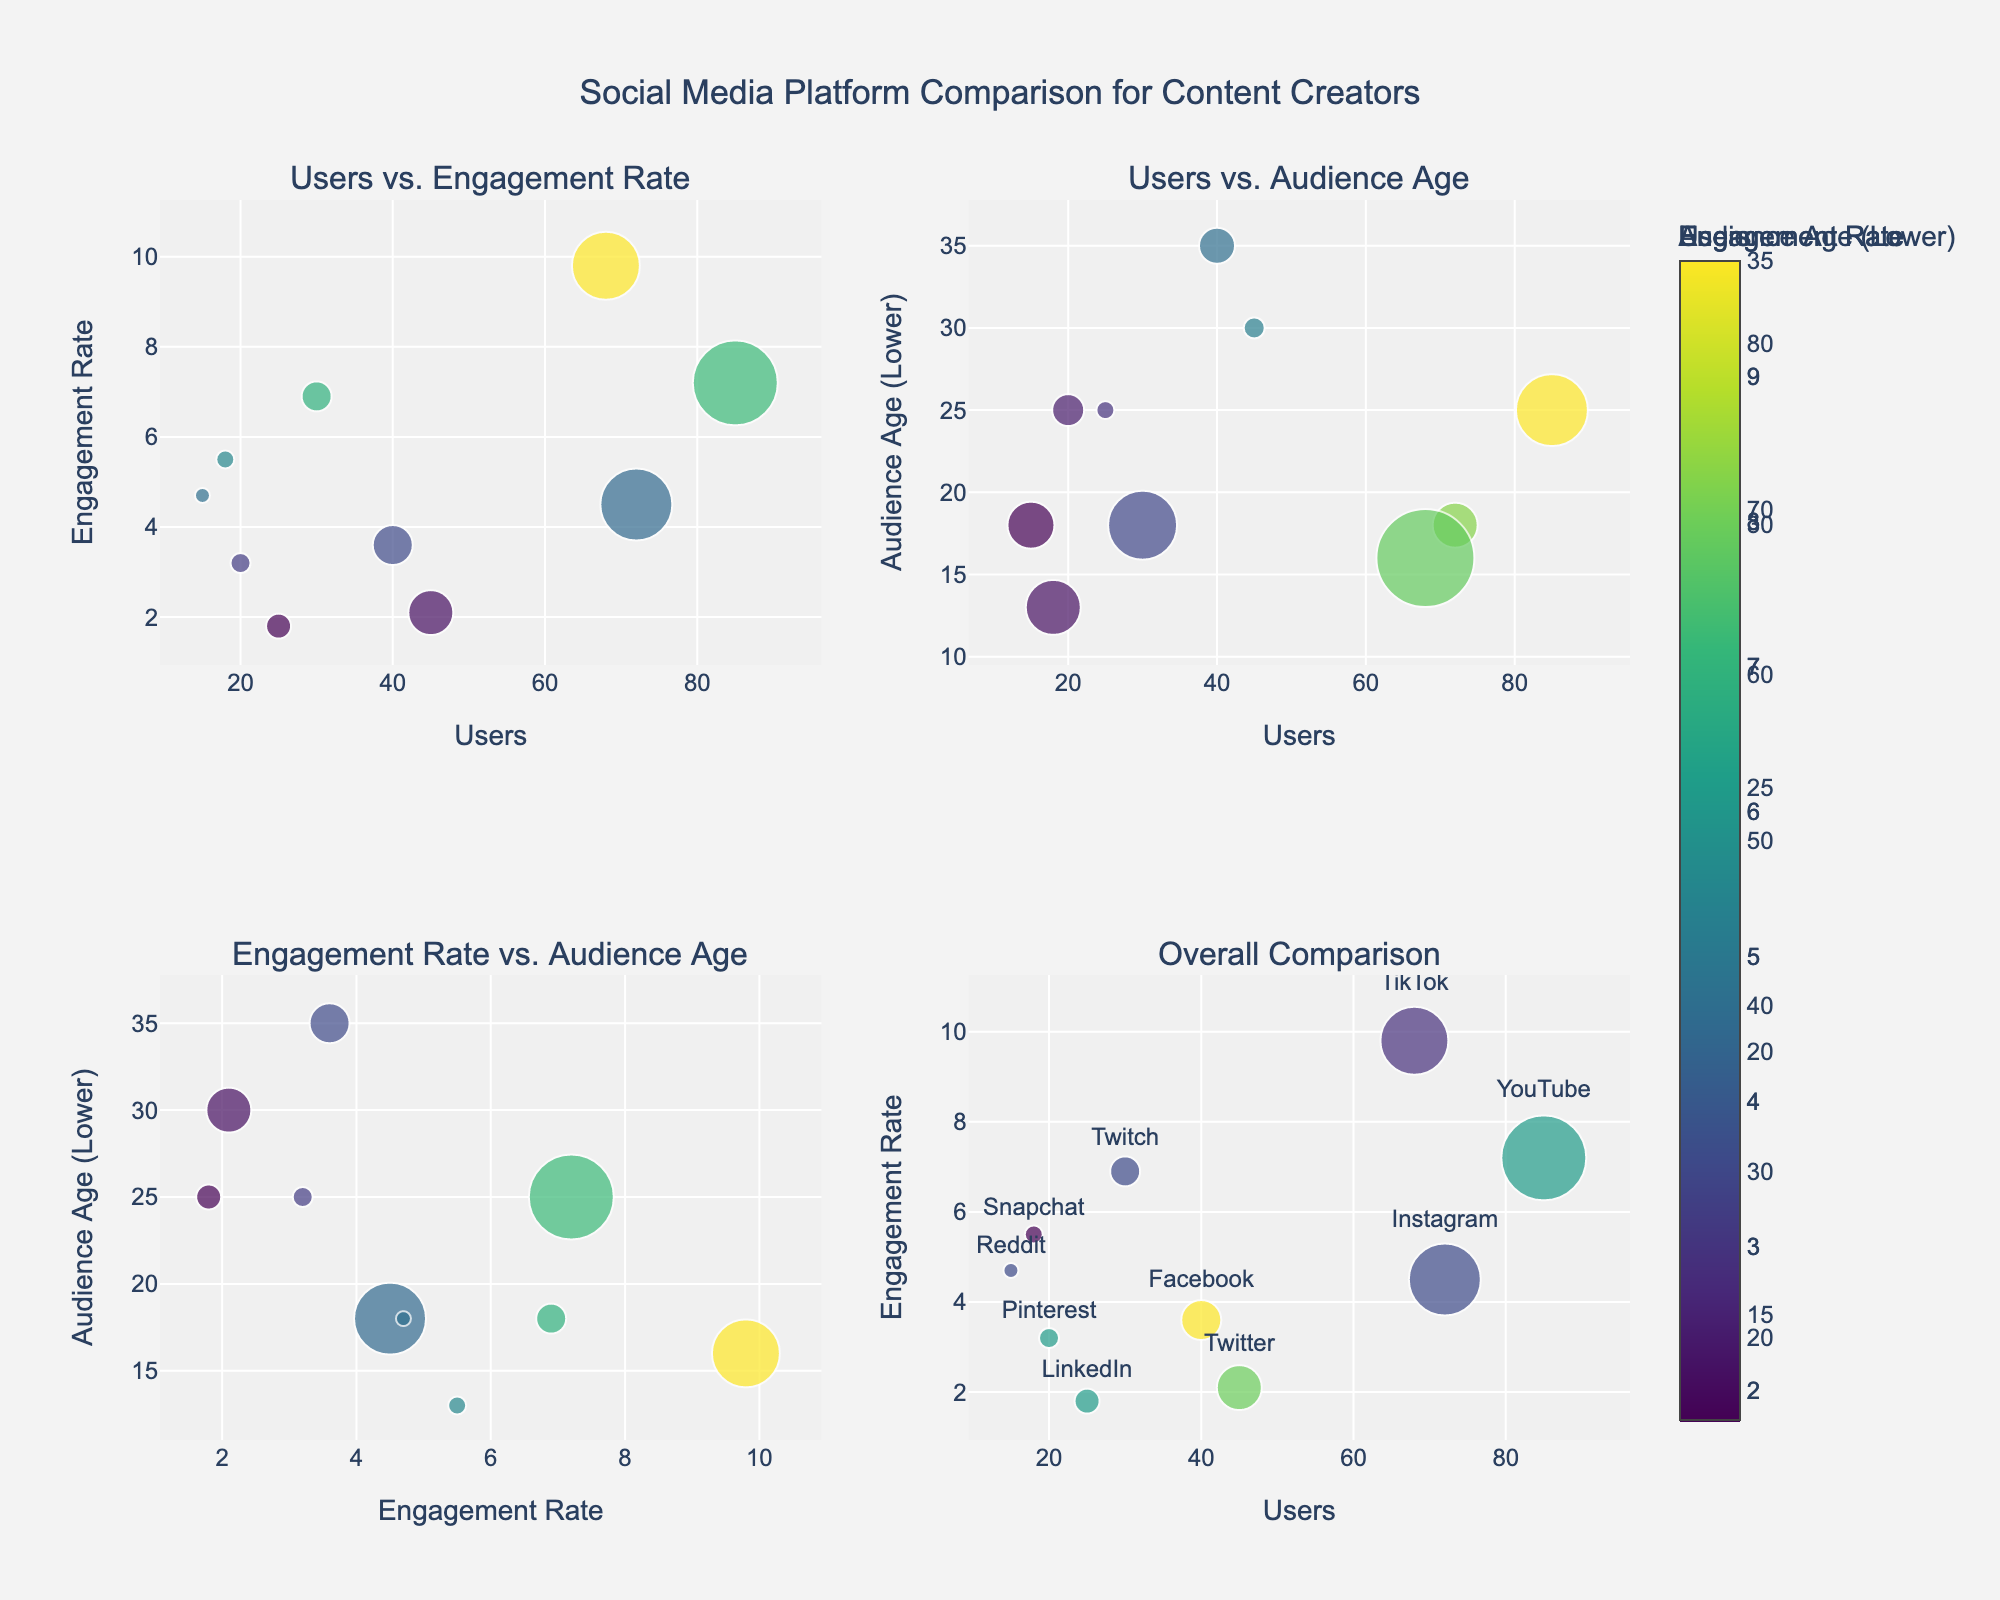What's the title of the overall figure? The title of the figure is prominently displayed at the top center. Observing it reveals the full title.
Answer: Social Media Platform Comparison for Content Creators How is the "Users vs. Engagement Rate" plot colored? The color in this plot represents the Engagement Rate, as indicated by the color bar next to the plot.
Answer: Engagement Rate Which platform has the highest engagement rate? Look at the y-axis of the first plot (Users vs. Engagement Rate) to pick the highest point. The bubble size helps by indicating larger user bases.
Answer: TikTok What is the relationship between the number of users and engagement rate for YouTube? Locate YouTube in the "Users vs. Engagement Rate" plot. Estimate the users from the x-axis and engagement rate from the y-axis position of the bubble.
Answer: 85 users and 7.2 engagement rate Which platform targets the youngest audience in the "Overall Comparison" plot? According to the audience age color scale, find the smallest number on the audience age color bar, and locate the corresponding platform in the plot.
Answer: Snapchat What is the most common audience age range across the platforms? Check the audience age values on the y-axes of the plots that represent it and the size of bubbles in the "Users vs. Audience Age" plot.
Answer: 18-24 Which platform has the largest bubble in the "Engagement Rate vs. Audience Age" plot and what does it represent? Find the largest bubble in this plot, then refer to the x- and y-positions for engagement rate and audience age, respectively, and the color for users.
Answer: YouTube for Users Compare the bubbles of Instagram and Twitter in the "Overall Comparison" plot. Which has higher Engagement Rate and by how much? Track Instagram and Twitter on the "Users vs. Engagement Rate" plot. The y-axis for engagement rate shows Instagram has more. Note the difference between their positions on the y-axis.
Answer: Instagram by 2.4 What does the bubble size represent in the "Users vs. Audience Age" plot? Observe the legend or marker section explanations in the plot to determine the variable represented by bubble size.
Answer: Engagement Rate Which platform has a higher engagement rate: Twitch or Reddit? In the "Users vs. Engagement Rate" plot, locate the bubbles for Twitch and Reddit, then compare their positions on the y-axis.
Answer: Reddit 